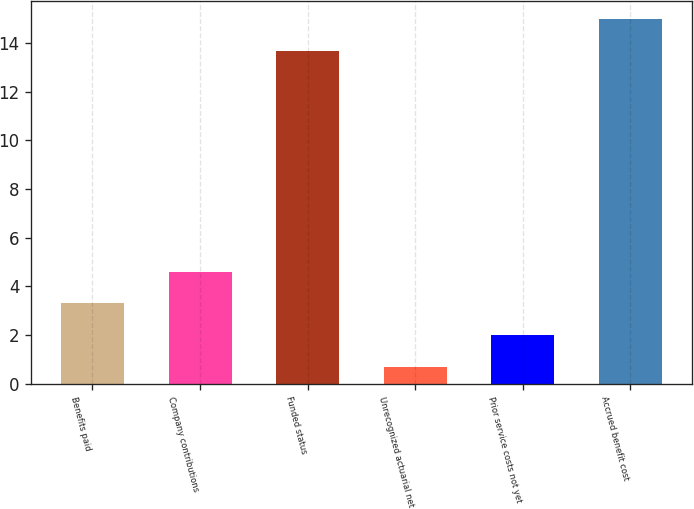Convert chart to OTSL. <chart><loc_0><loc_0><loc_500><loc_500><bar_chart><fcel>Benefits paid<fcel>Company contributions<fcel>Funded status<fcel>Unrecognized actuarial net<fcel>Prior service costs not yet<fcel>Accrued benefit cost<nl><fcel>3.3<fcel>4.6<fcel>13.7<fcel>0.7<fcel>2<fcel>15<nl></chart> 